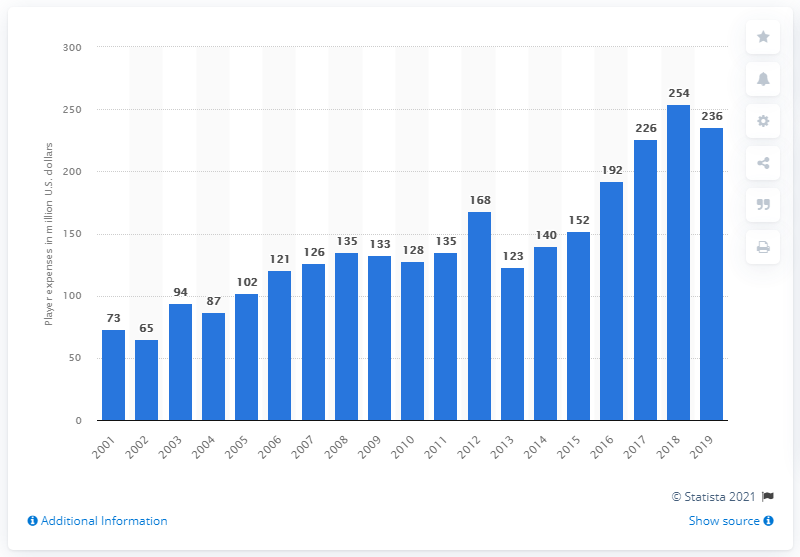List a handful of essential elements in this visual. The expenses of the Jacksonville Jaguars player in the 2019 season were $236 million. 